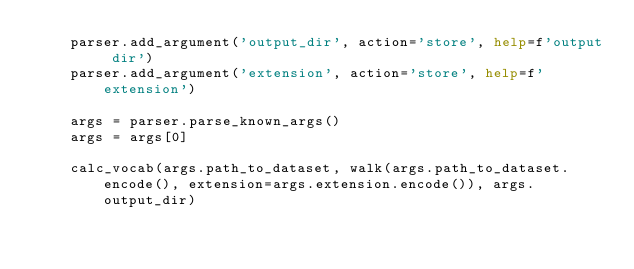Convert code to text. <code><loc_0><loc_0><loc_500><loc_500><_Python_>    parser.add_argument('output_dir', action='store', help=f'output dir')
    parser.add_argument('extension', action='store', help=f'extension')

    args = parser.parse_known_args()
    args = args[0]

    calc_vocab(args.path_to_dataset, walk(args.path_to_dataset.encode(), extension=args.extension.encode()), args.output_dir)</code> 